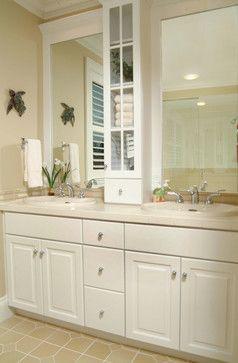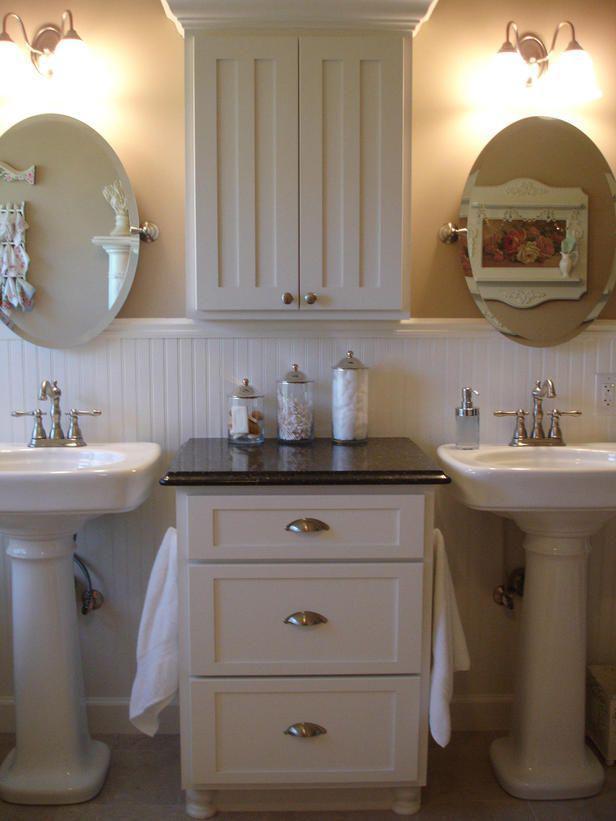The first image is the image on the left, the second image is the image on the right. Examine the images to the left and right. Is the description "There is a single mirror over the counter in the image on the right." accurate? Answer yes or no. No. The first image is the image on the left, the second image is the image on the right. Evaluate the accuracy of this statement regarding the images: "A bathroom includes two oval shapes on the wall flanking a white cabinet, with lights above the ovals.". Is it true? Answer yes or no. Yes. 